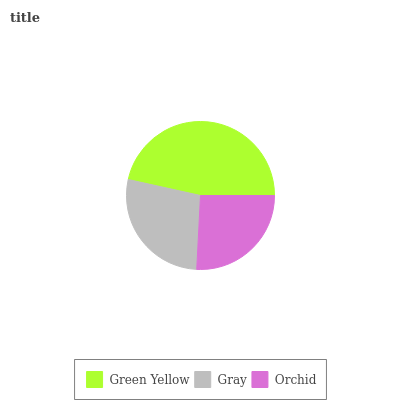Is Orchid the minimum?
Answer yes or no. Yes. Is Green Yellow the maximum?
Answer yes or no. Yes. Is Gray the minimum?
Answer yes or no. No. Is Gray the maximum?
Answer yes or no. No. Is Green Yellow greater than Gray?
Answer yes or no. Yes. Is Gray less than Green Yellow?
Answer yes or no. Yes. Is Gray greater than Green Yellow?
Answer yes or no. No. Is Green Yellow less than Gray?
Answer yes or no. No. Is Gray the high median?
Answer yes or no. Yes. Is Gray the low median?
Answer yes or no. Yes. Is Orchid the high median?
Answer yes or no. No. Is Green Yellow the low median?
Answer yes or no. No. 